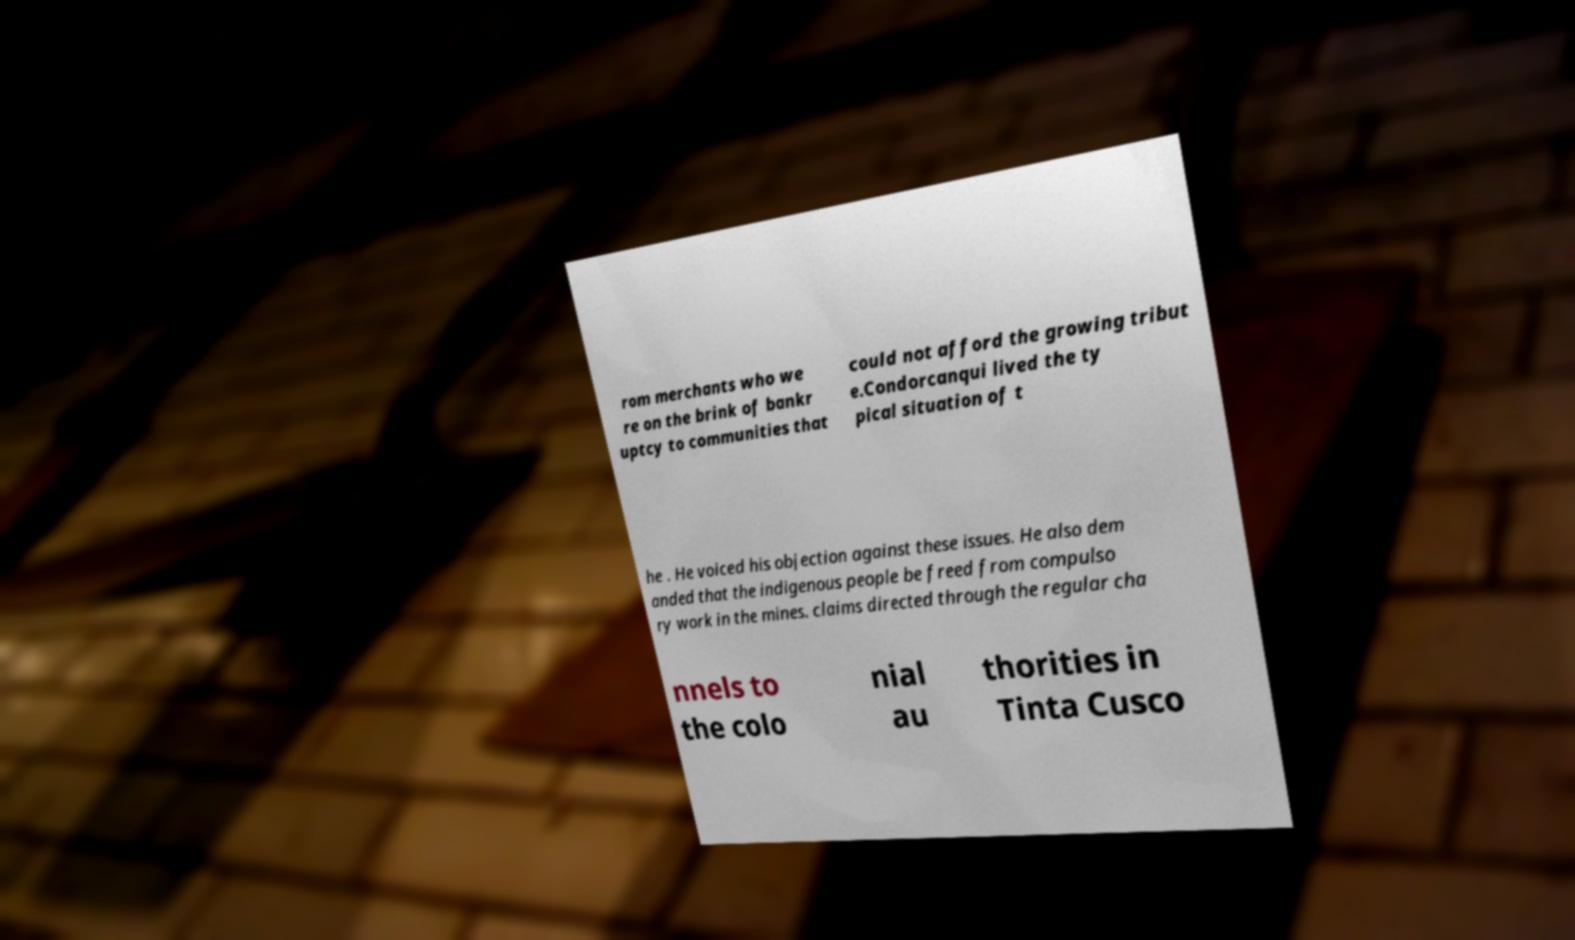Can you read and provide the text displayed in the image?This photo seems to have some interesting text. Can you extract and type it out for me? rom merchants who we re on the brink of bankr uptcy to communities that could not afford the growing tribut e.Condorcanqui lived the ty pical situation of t he . He voiced his objection against these issues. He also dem anded that the indigenous people be freed from compulso ry work in the mines. claims directed through the regular cha nnels to the colo nial au thorities in Tinta Cusco 